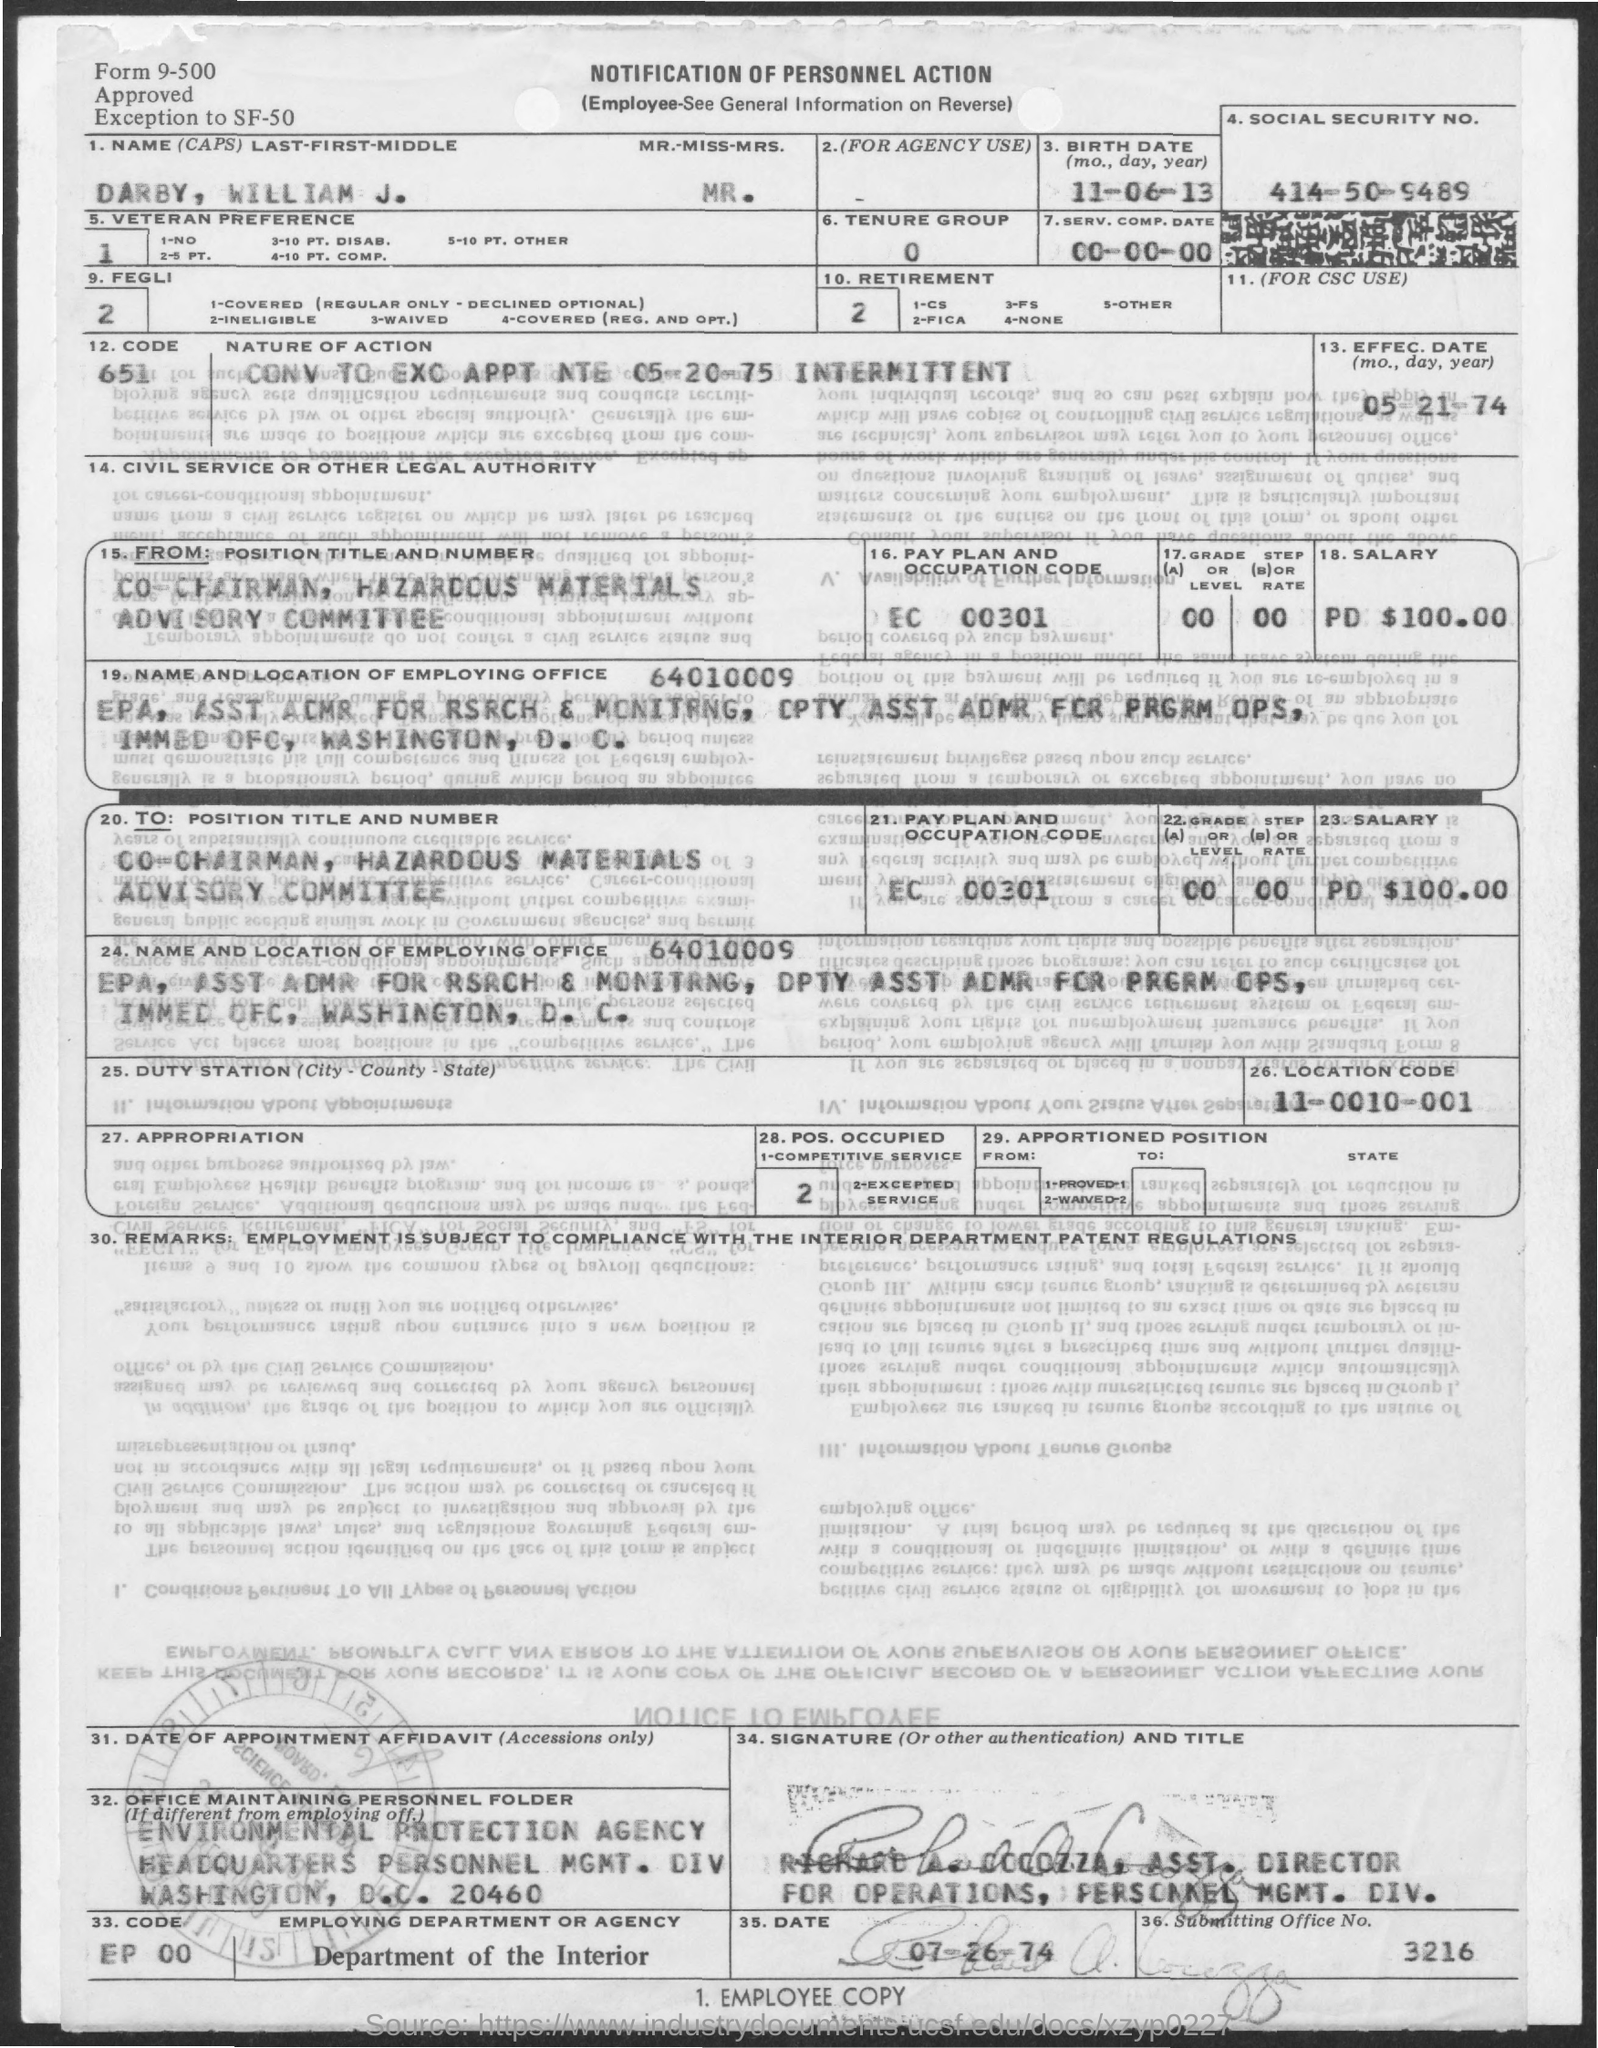What is the Name  Last-first-middle?
Offer a terse response. Darby, william j. What is the Birth date?
Offer a terse response. 11-06-13. What is the Effec. Date?
Your response must be concise. 05-21-74. What is the Location Code?
Your answer should be compact. 11-0010-001. What is the Pay Plan and Occupation Code?
Give a very brief answer. EC 00301. What is the Salary?
Ensure brevity in your answer.  Pd $100.00. What is the Employing Department or Agency?
Offer a very short reply. Department of the Interior. What is the Code?
Ensure brevity in your answer.  EP 00. What is the Submitting Office No.?
Provide a short and direct response. 3216. 